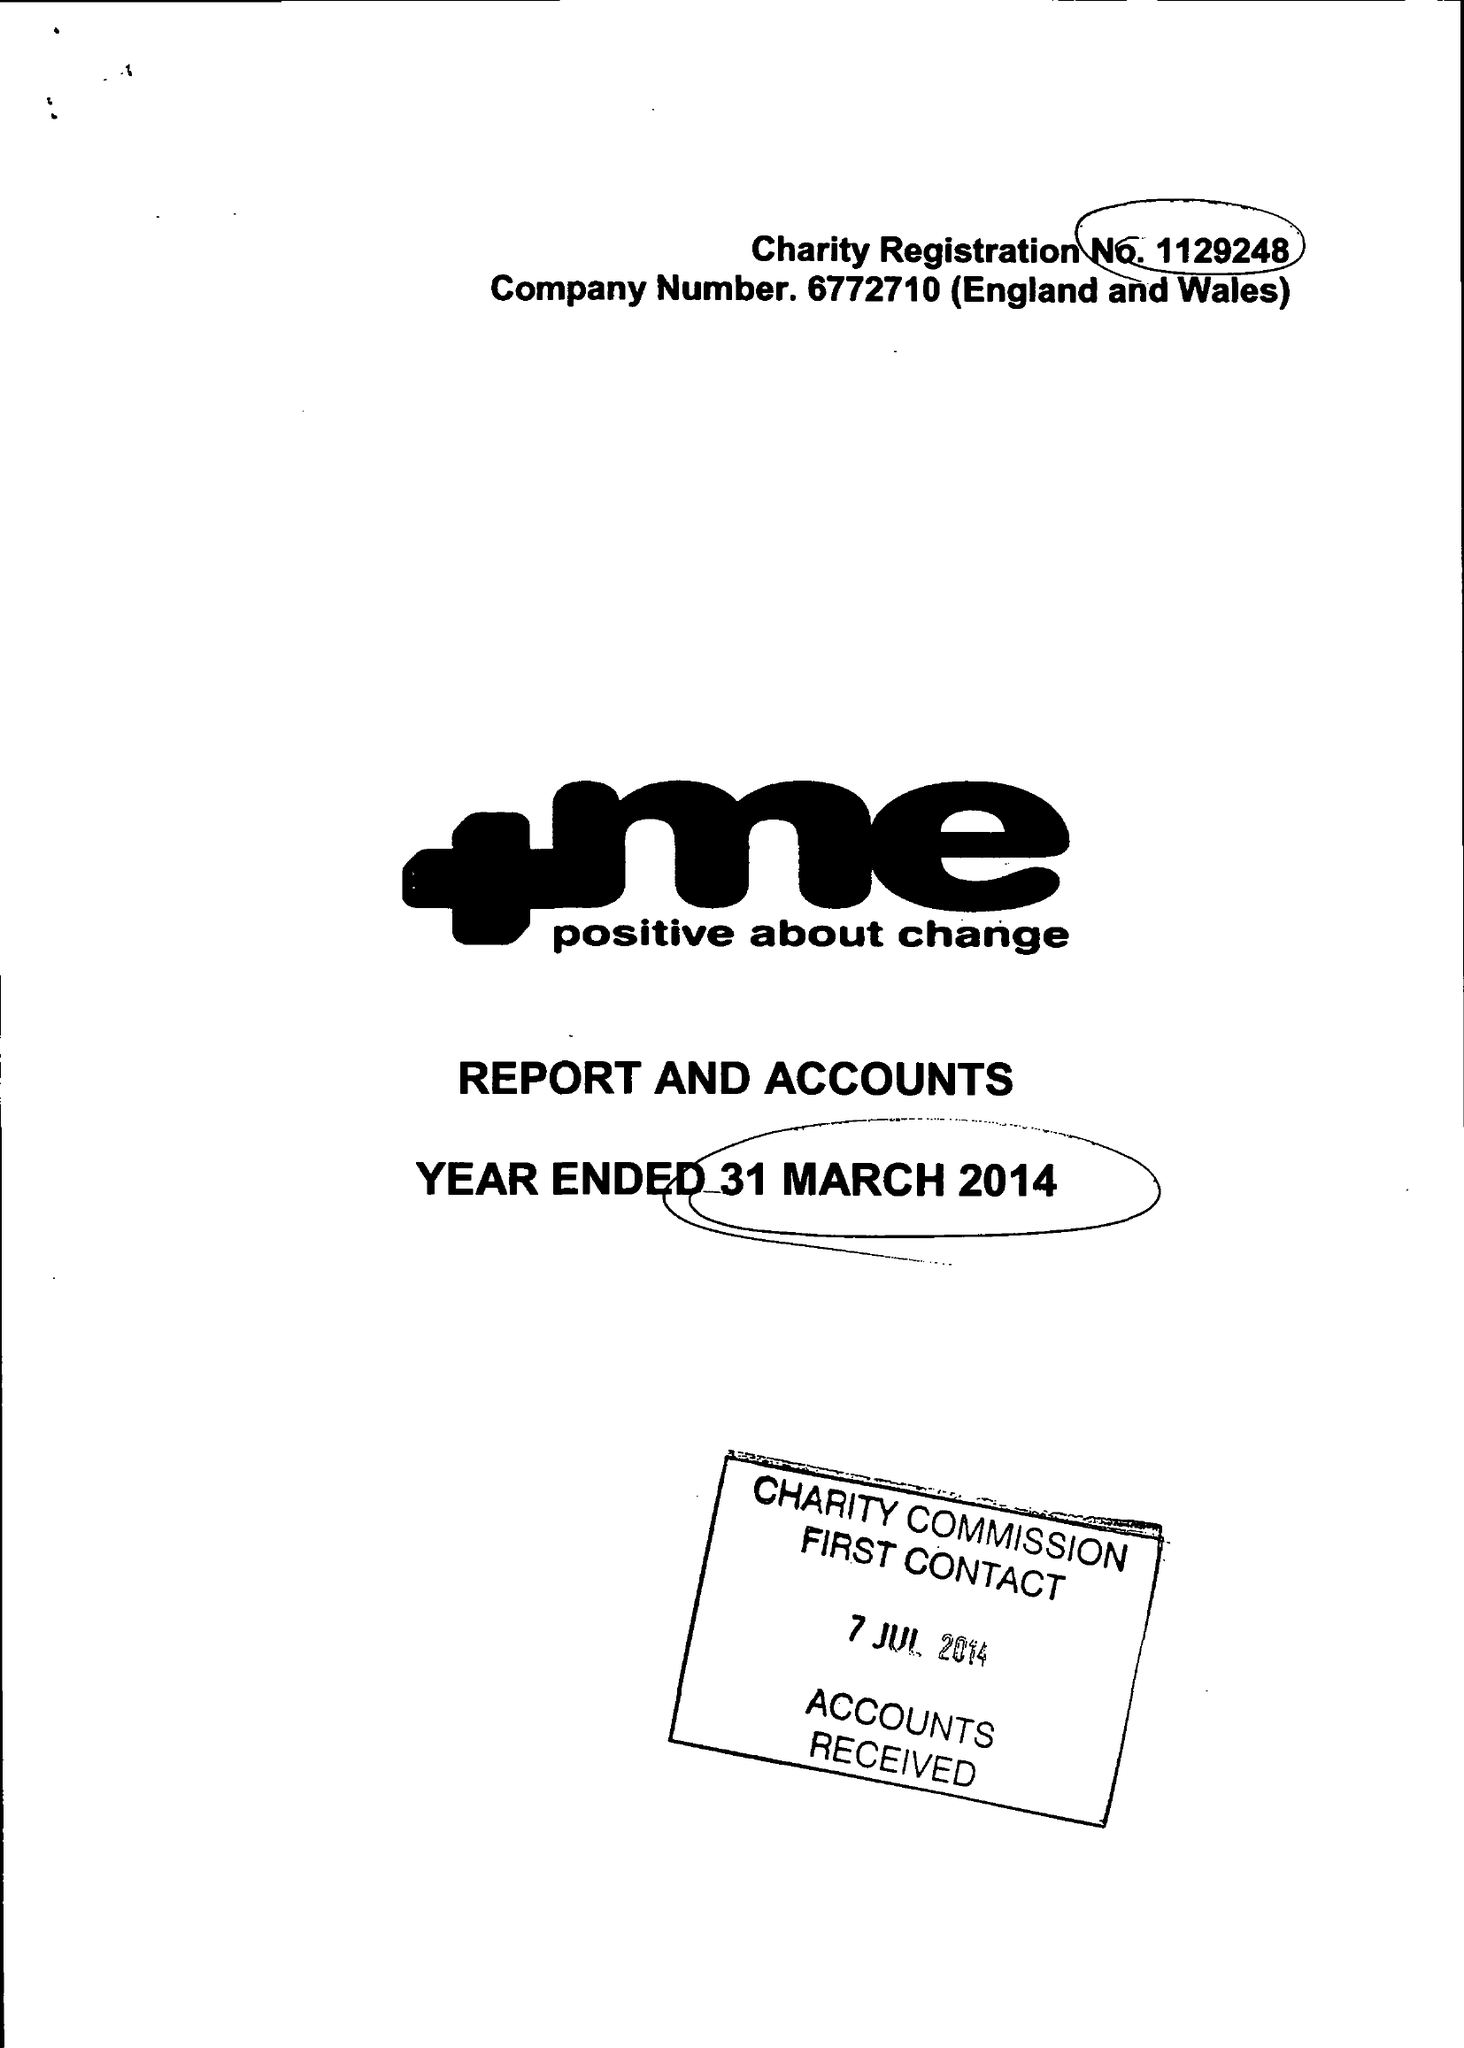What is the value for the address__postcode?
Answer the question using a single word or phrase. S71 1AN 